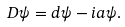Convert formula to latex. <formula><loc_0><loc_0><loc_500><loc_500>D \psi = d \psi - i a \psi .</formula> 